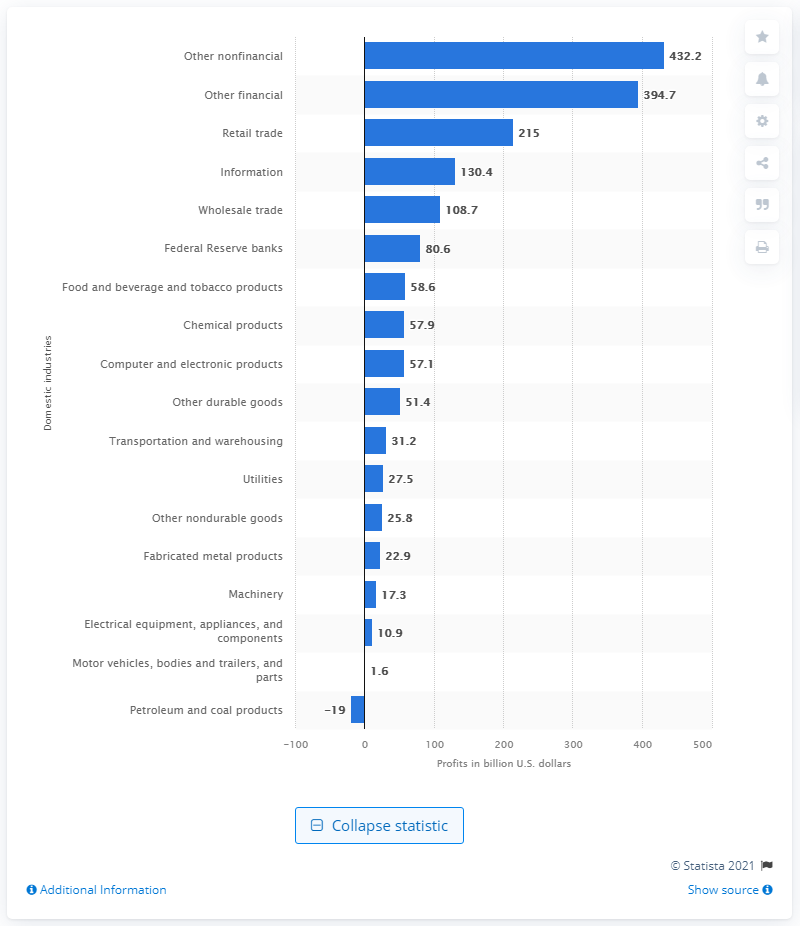Give some essential details in this illustration. The chemical products industry generated approximately 57.9 billion U.S. dollars in revenue in 2020. 